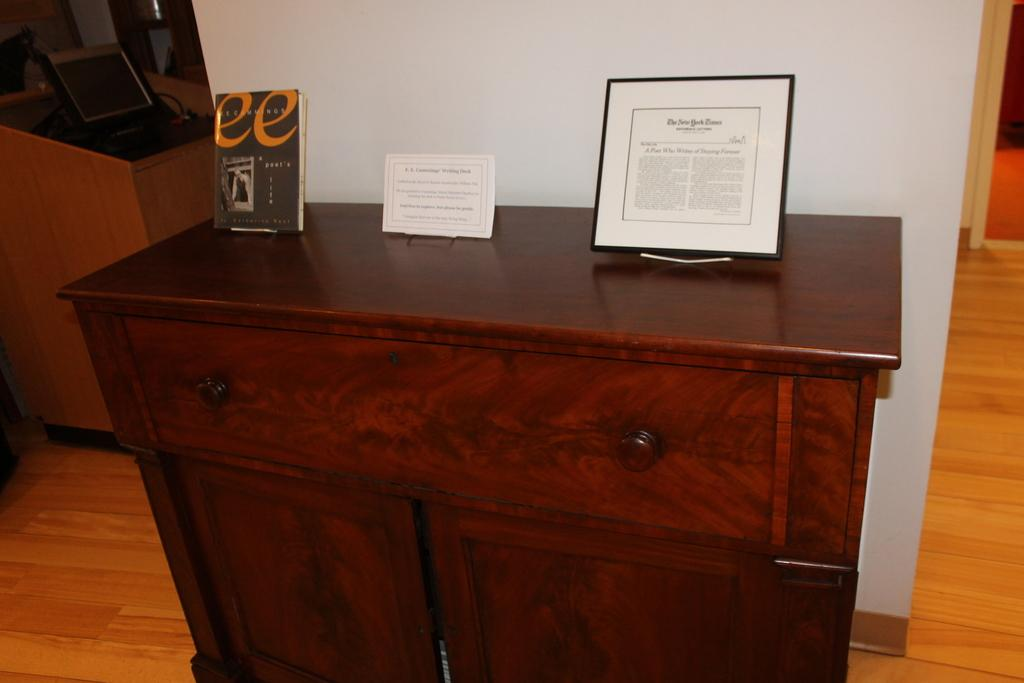How many photo frames are visible in the image? There are two photo frames in the image. What else can be seen on the desk besides the photo frames? There is a book on the desk. What electronic device is present on the table? There is a laptop on the table. What color is the wall visible in the image? The wall visible in the image is white. What type of flooring is present in the image? There is a wooden floor in the image. What does the dad do with the book in the image? There is no dad present in the image, and therefore no interaction with the book can be observed. How does the brother rub the wooden floor in the image? There is no brother present in the image, and therefore no rubbing of the wooden floor can be observed. 